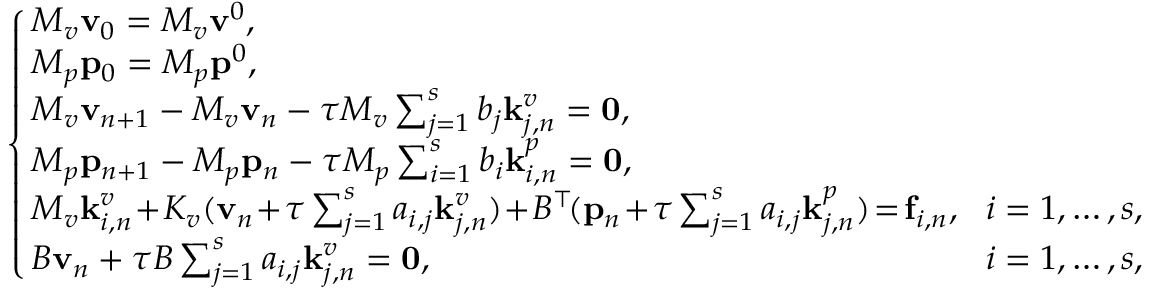Convert formula to latex. <formula><loc_0><loc_0><loc_500><loc_500>\left \{ \begin{array} { l l } { \, M _ { v } v _ { 0 } = M _ { v } v ^ { 0 } , } \\ { \, M _ { p } p _ { 0 } = M _ { p } p ^ { 0 } , } \\ { \, M _ { v } v _ { n + 1 } - M _ { v } v _ { n } - \tau M _ { v } \sum _ { j = 1 } ^ { s } b _ { j } k _ { j , n } ^ { v } = 0 , } & \\ { \, M _ { p } p _ { n + 1 } - M _ { p } p _ { n } - \tau M _ { p } \sum _ { i = 1 } ^ { s } b _ { i } k _ { i , n } ^ { p } = 0 , } & \\ { \, M _ { v } k _ { i , n } ^ { v } \, + \, K _ { v } ( v _ { n } \, + \, \tau \sum _ { j = 1 } ^ { s } a _ { i , j } k _ { j , n } ^ { v } ) \, + \, B ^ { \top } \, ( p _ { n } \, + \, \tau \sum _ { j = 1 } ^ { s } a _ { i , j } k _ { j , n } ^ { p } ) \, = \, f _ { i , n } , } & { \, i = 1 , \dots , s , } \\ { \, B v _ { n } + \tau B \sum _ { j = 1 } ^ { s } a _ { i , j } k _ { j , n } ^ { v } = 0 , } & { \, i = 1 , \dots , s , } \end{array}</formula> 